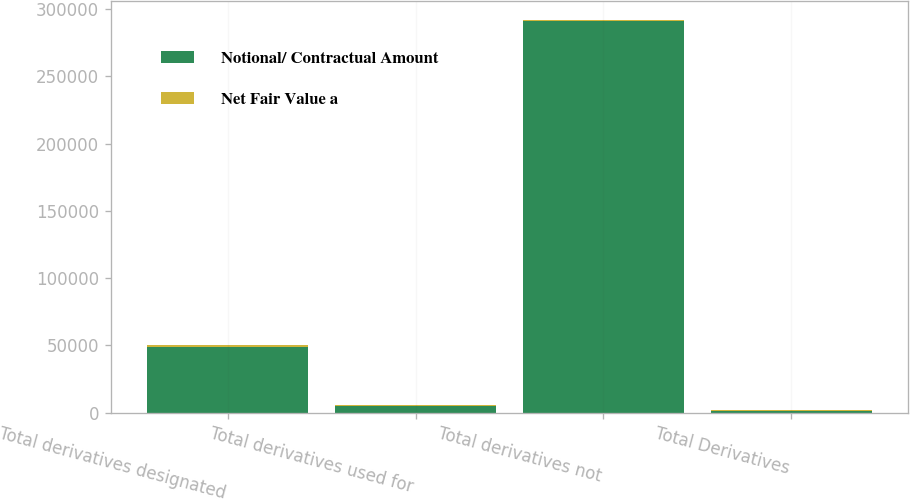Convert chart. <chart><loc_0><loc_0><loc_500><loc_500><stacked_bar_chart><ecel><fcel>Total derivatives designated<fcel>Total derivatives used for<fcel>Total derivatives not<fcel>Total Derivatives<nl><fcel>Notional/ Contractual Amount<fcel>49061<fcel>5390<fcel>291256<fcel>1207<nl><fcel>Net Fair Value a<fcel>1075<fcel>425<fcel>132<fcel>1207<nl></chart> 